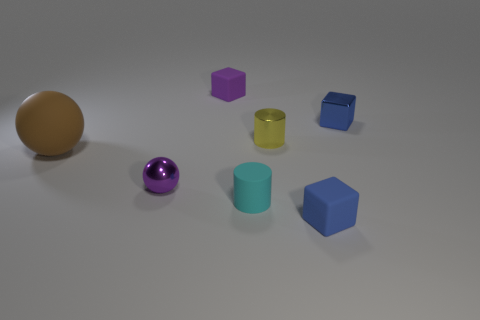There is a block that is the same color as the metallic ball; what size is it?
Offer a terse response. Small. There is a yellow metal object; does it have the same size as the rubber object to the left of the purple matte thing?
Keep it short and to the point. No. Is there a large shiny cylinder that has the same color as the tiny metal block?
Your answer should be compact. No. There is a sphere that is the same material as the purple cube; what is its size?
Your response must be concise. Large. Is the small purple sphere made of the same material as the tiny yellow cylinder?
Your answer should be compact. Yes. The small thing that is on the right side of the rubber block that is right of the small matte thing behind the tiny cyan rubber thing is what color?
Keep it short and to the point. Blue. The tiny cyan object has what shape?
Offer a very short reply. Cylinder. There is a rubber sphere; does it have the same color as the matte cube that is on the right side of the purple matte object?
Make the answer very short. No. Are there an equal number of small cyan matte cylinders that are in front of the small blue matte cube and small yellow rubber balls?
Your answer should be compact. Yes. How many shiny objects have the same size as the rubber ball?
Your response must be concise. 0. 